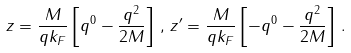Convert formula to latex. <formula><loc_0><loc_0><loc_500><loc_500>z = \frac { M } { q k _ { F } } \left [ q ^ { 0 } - \frac { q ^ { 2 } } { 2 M } \right ] \, , \, z ^ { \prime } = \frac { M } { q k _ { F } } \left [ - q ^ { 0 } - \frac { q ^ { 2 } } { 2 M } \right ] \, .</formula> 